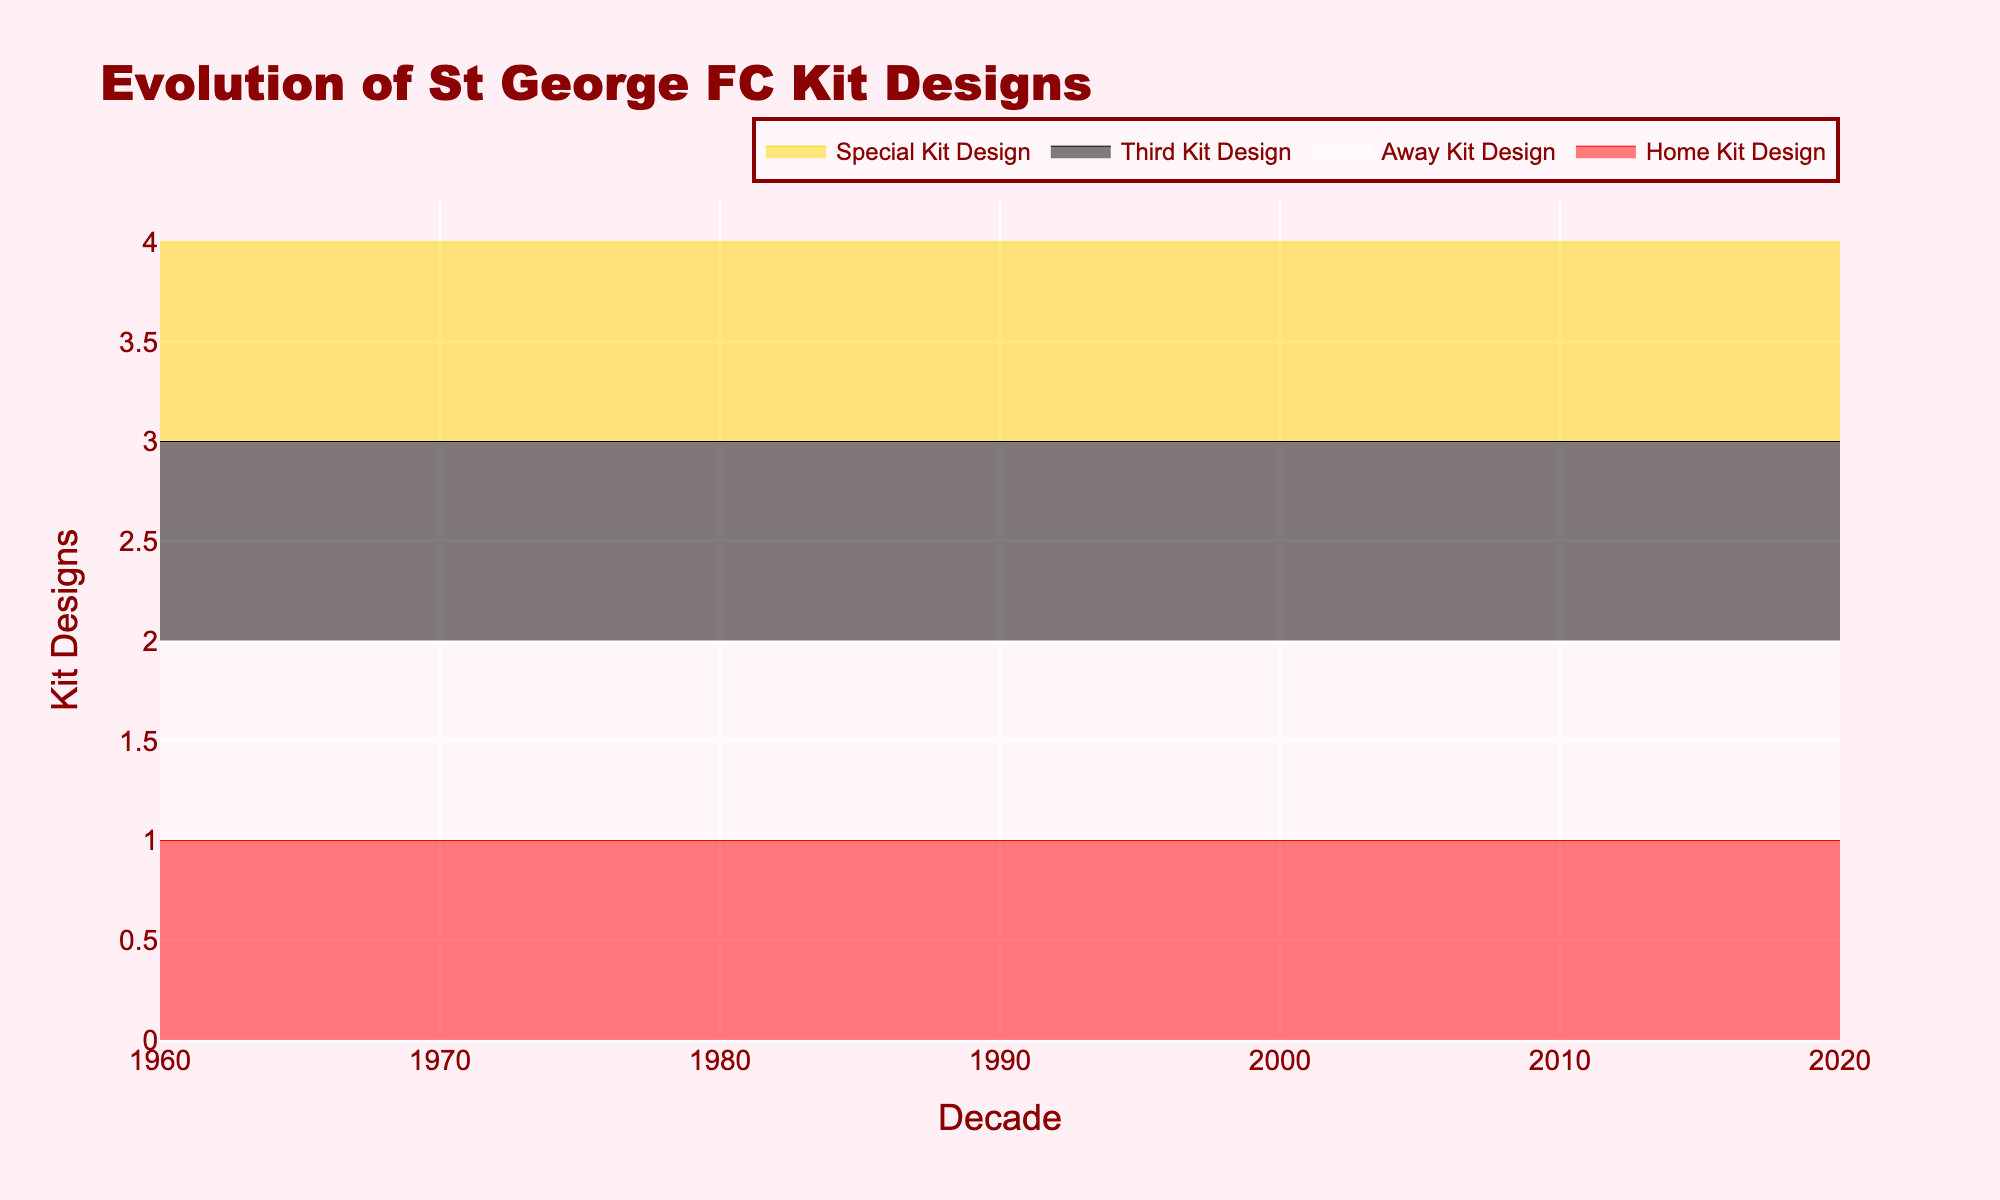what is the title of the graph? The title is prominently displayed at the top of the graph, showing the main topic that the graph represents. The title of this figure is 'Evolution of St George FC Kit Designs'.
Answer: Evolution of St George FC Kit Designs Which decade introduced the most kit designs at once? By observing the y-values across the decades, we see the introduction of the "Limited Edition Heritage Kit" in the 2020s in addition to the home, away, and third kits, making it 4 kit designs displayed in the 2020s.
Answer: 2020s How many different kit types were introduced by St George FC in the 1970s based on the graph? The graph shows lines representing three kit types that appear above the x-axis for the 1970s, specifically the home, away, and third kit designs.
Answer: 3 Which specific kits were not introduced until later decades? In the graph, we can see that the "Third Kit Design" first appears in 1980, and "Special Kit Design" first appears in 2020.
Answer: Third Kit Design (1980), Special Kit Design (2020) How did the home kit design change from the 1960s to the 1970s? We compare the home kit line from the 1960s, which represents 'Red and White Stripes,' to the 1970s, where it changes to 'Red Shirt with White Shorts.'
Answer: Red and White Stripes to Red Shirt with White Shorts Which decades displayed no special kit designs? The y-values for "Special Kit Design" are zero for the 1960s, 1970s, 1980s, 1990s, and 2000s, indicating no special kit designs in those decades.
Answer: 1960s, 1970s, 1980s, 1990s, 2000s Was there a decade where St George FC did not have a third kit? By examining the lines, we can see that the y-value for the "Third Kit Design" is zero in the data for the 1960s and 1970s.
Answer: 1960s, 1970s Which kit saw the largest increase in 2020? Observing the y-values, "Special Kit Design" had no values (N/A) until 2020, making it the largest increase since it starts being represented in that decade.
Answer: Special Kit Design What is the trend for the home kit design from 1960 to 2020? Following the y-axis for the "Home Kit Design" highlights, the y-value remains constant across all decades indicating continuous presence, changing only in style descriptions.
Answer: Constant through all decades Which kit types had a presence across all decades? Observing the lines for each kit type, the "Home Kit Design" maintains a non-zero y-value across all decades, ensuring its constant presence.
Answer: Home Kit Design 